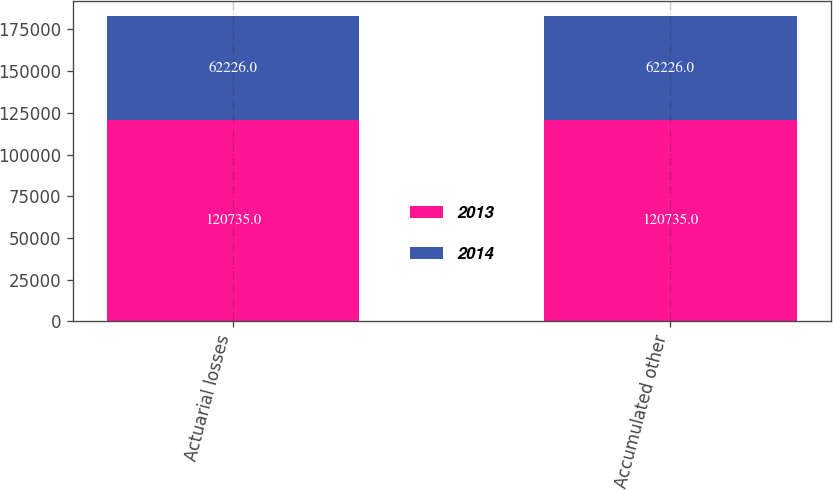<chart> <loc_0><loc_0><loc_500><loc_500><stacked_bar_chart><ecel><fcel>Actuarial losses<fcel>Accumulated other<nl><fcel>2013<fcel>120735<fcel>120735<nl><fcel>2014<fcel>62226<fcel>62226<nl></chart> 